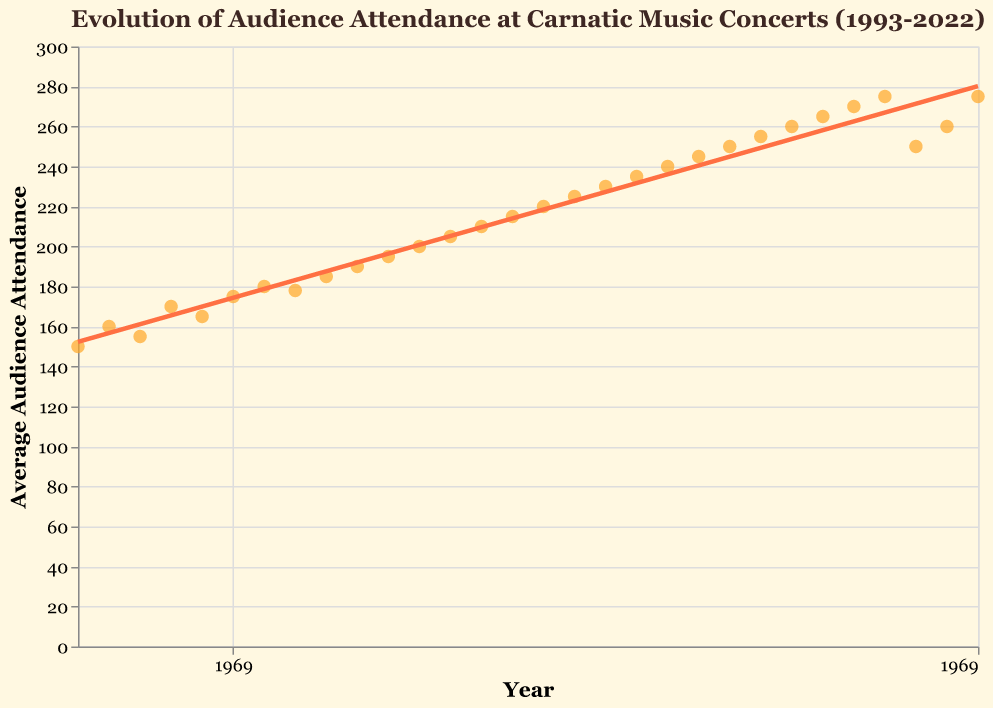What is the title of the plot? The title is displayed prominently at the top of the plot. It reads, "Evolution of Audience Attendance at Carnatic Music Concerts (1993-2022)".
Answer: Evolution of Audience Attendance at Carnatic Music Concerts (1993-2022) How many data points are there in the plot? Each year from 1993 to 2022 has a corresponding data point for average audience attendance. Counting from 1993 to 2022, there are 30 data points in total.
Answer: 30 What is the highest average audience attendance recorded? Look at the y-axis and find the highest value. In the year 2022, the average audience attendance is 275, which is the highest.
Answer: 275 In which year did the average audience attendance decline compared to the previous year? By observing the trend from one data point to the next, identify if the y-value decreases. This occurs from 2019 (275) to 2020 (250) due to a significant drop.
Answer: 2020 What is the overall trend of the audience attendance over the past three decades? The trend line provides an overall summary of the data's direction. The line shows a positive slope, indicating a general increase in audience attendance from 1993 to 2022.
Answer: Increasing What was the average audience attendance in the year 2000? Locate the data point for the year 2000 on the x-axis and check its corresponding y-value. The average audience attendance in 2000 is 178.
Answer: 178 Compare the average audience attendance in 1993 and 2022. How much did it change? The attendance in 1993 is 150, and in 2022 it is 275. The difference is 275 - 150, which equals 125.
Answer: 125 What effect did the year 2020 have on the trend when compared with the previous years? The average audience attendance dropped significantly from 275 in 2019 to 250 in 2020, breaking the increasing trend seen in previous years.
Answer: Significant drop Calculate the average audience attendance over the first decade (1993-2002). Sum the attendance from 1993 to 2002 (150+160+155+170+165+175+180+178+185+190) and divide by the number of years (10). Total is 1708, so the average is 1708/10 = 170.8.
Answer: 170.8 What is the general shape of the data points between the years 1993 and 2022? The dots follow a mostly upward trajectory with a dip in 2020, but the general shape indicates a positive trend or upward slope over time.
Answer: Upward slope with a dip in 2020 